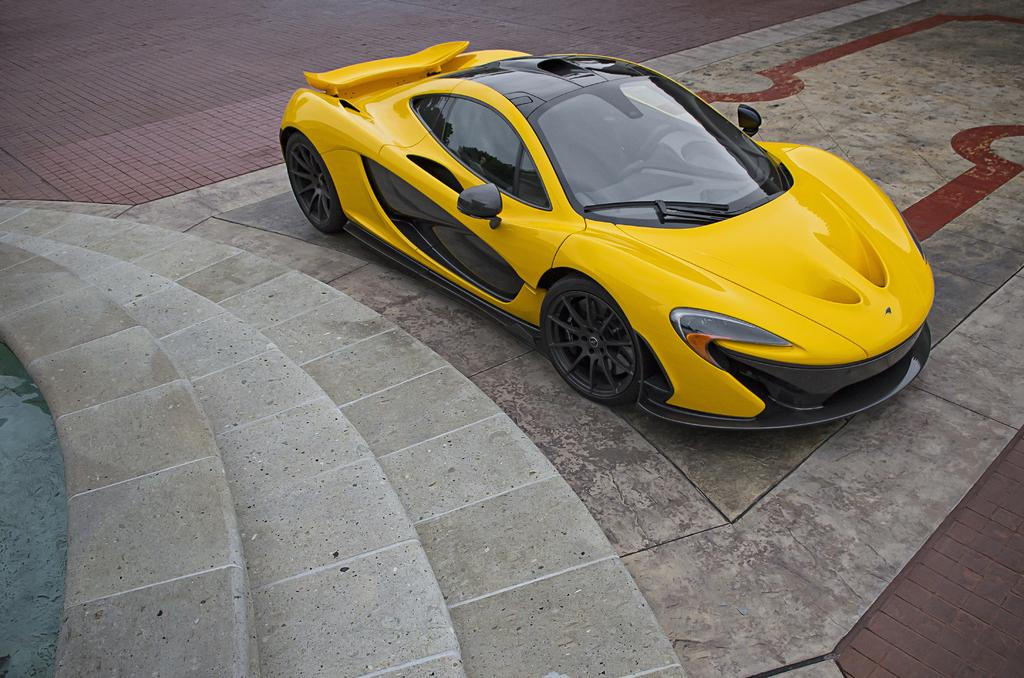What color is the car in the image? The car in the image is yellow. Where is the car located in relation to other objects? The car is parked near stairs. What can be seen on the left side of the image? There is water visible on the left side of the image. What type of police mine is visible in the image? There is no police mine present in the image. What color are the trousers of the person standing next to the car? There is no person standing next to the car in the image. 